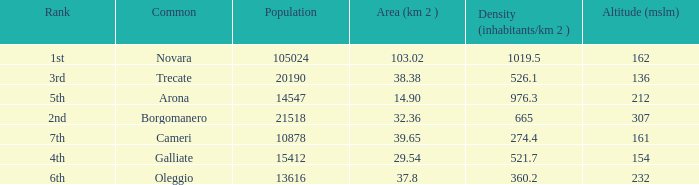Which common has an area (km2) of 103.02? Novara. Parse the full table. {'header': ['Rank', 'Common', 'Population', 'Area (km 2 )', 'Density (inhabitants/km 2 )', 'Altitude (mslm)'], 'rows': [['1st', 'Novara', '105024', '103.02', '1019.5', '162'], ['3rd', 'Trecate', '20190', '38.38', '526.1', '136'], ['5th', 'Arona', '14547', '14.90', '976.3', '212'], ['2nd', 'Borgomanero', '21518', '32.36', '665', '307'], ['7th', 'Cameri', '10878', '39.65', '274.4', '161'], ['4th', 'Galliate', '15412', '29.54', '521.7', '154'], ['6th', 'Oleggio', '13616', '37.8', '360.2', '232']]} 